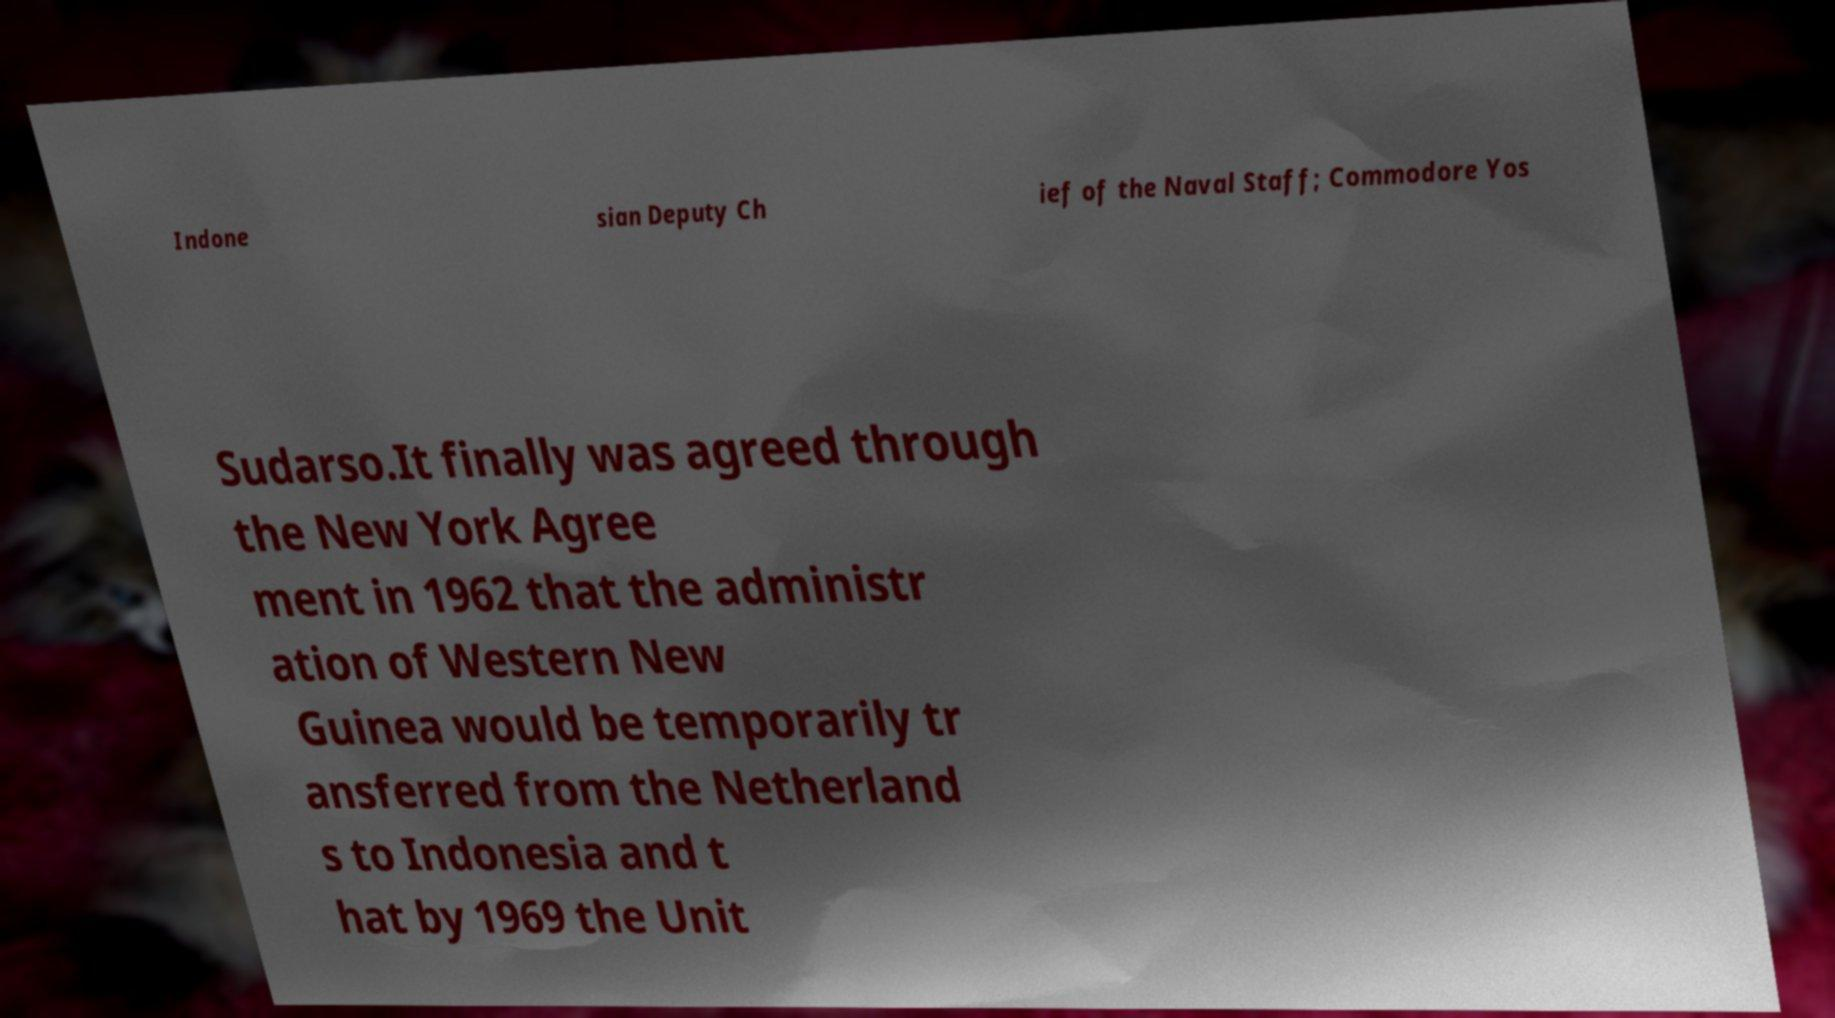I need the written content from this picture converted into text. Can you do that? Indone sian Deputy Ch ief of the Naval Staff; Commodore Yos Sudarso.It finally was agreed through the New York Agree ment in 1962 that the administr ation of Western New Guinea would be temporarily tr ansferred from the Netherland s to Indonesia and t hat by 1969 the Unit 